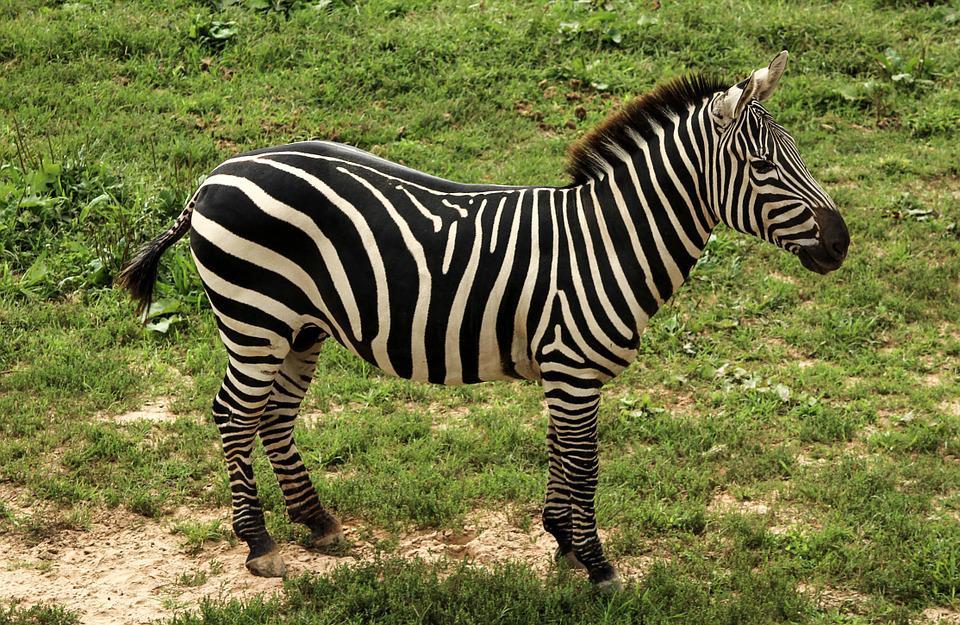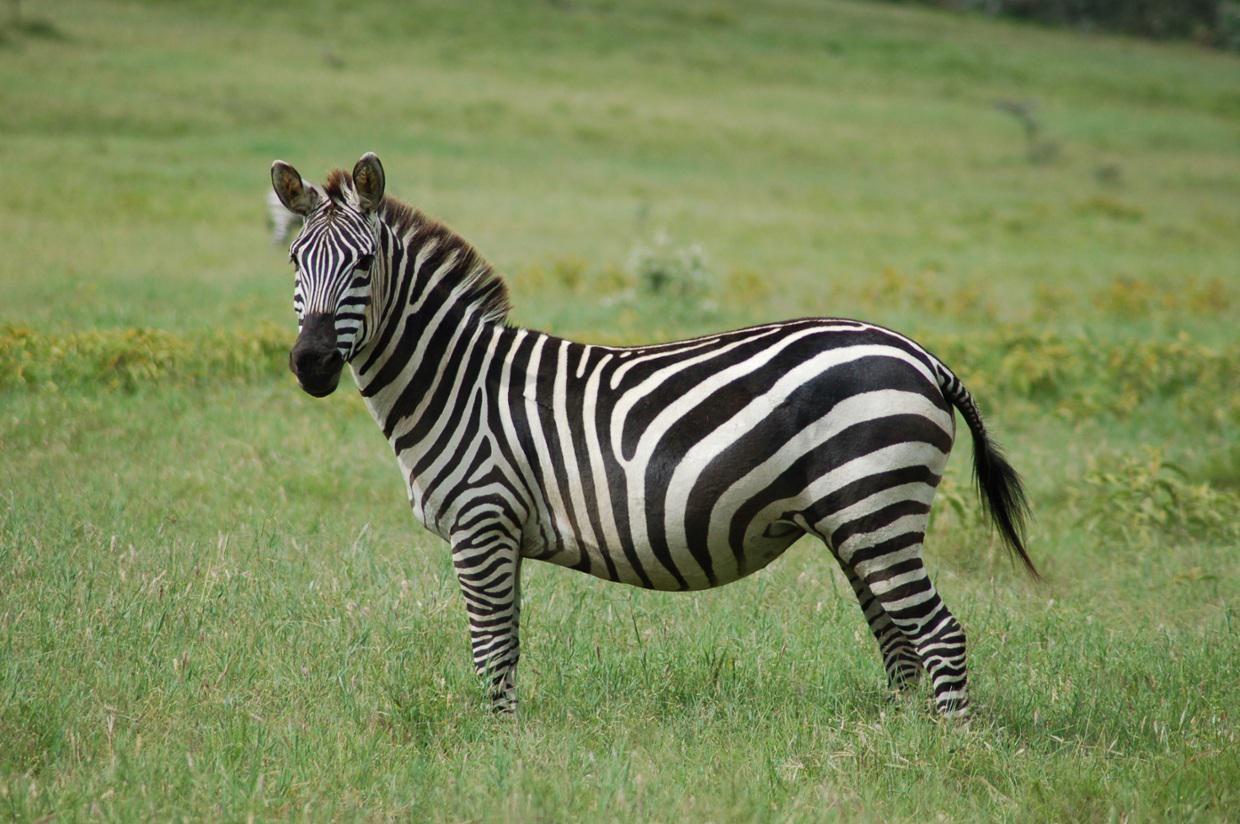The first image is the image on the left, the second image is the image on the right. Assess this claim about the two images: "In one image, two similarly-sized zebras are standing side by side in the same direction.". Correct or not? Answer yes or no. No. The first image is the image on the left, the second image is the image on the right. Analyze the images presented: Is the assertion "A young zebra can be seen with at least one adult zebra in one of the images." valid? Answer yes or no. No. 